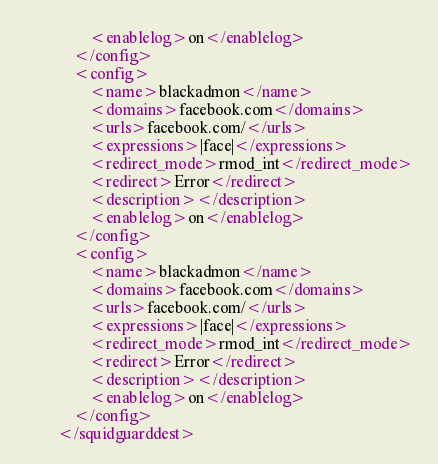Convert code to text. <code><loc_0><loc_0><loc_500><loc_500><_XML_>				<enablelog>on</enablelog>
			</config>
			<config>
				<name>blackadmon</name>
				<domains>facebook.com</domains>
				<urls>facebook.com/</urls>
				<expressions>|face|</expressions>
				<redirect_mode>rmod_int</redirect_mode>
				<redirect>Error</redirect>
				<description></description>
				<enablelog>on</enablelog>
			</config>
			<config>
				<name>blackadmon</name>
				<domains>facebook.com</domains>
				<urls>facebook.com/</urls>
				<expressions>|face|</expressions>
				<redirect_mode>rmod_int</redirect_mode>
				<redirect>Error</redirect>
				<description></description>
				<enablelog>on</enablelog>
			</config>
		</squidguarddest></code> 